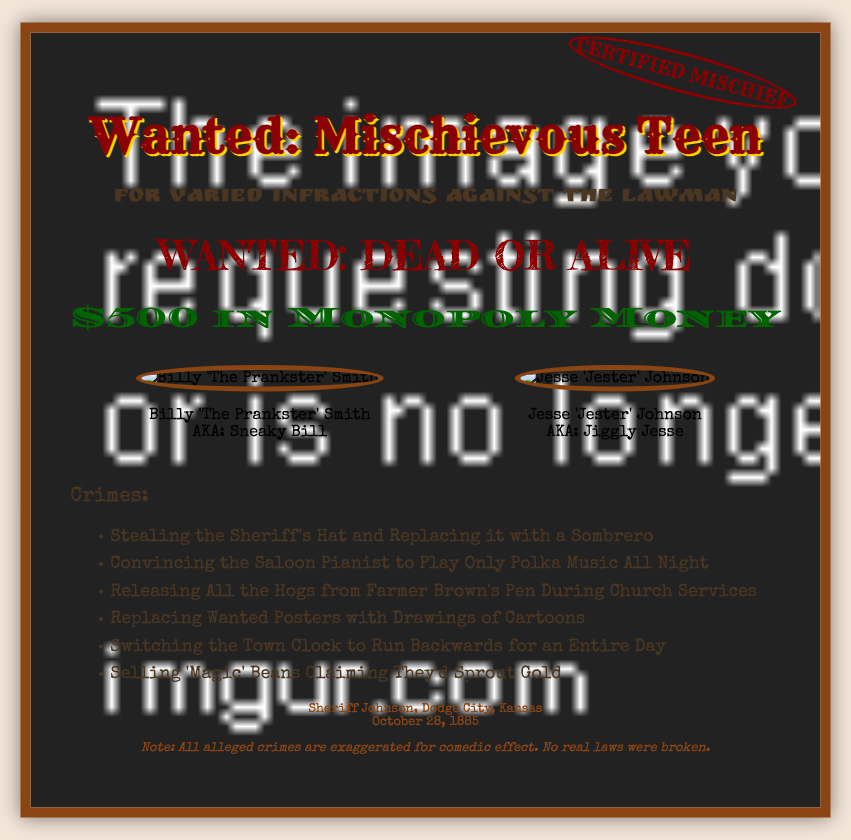What is the title of the document? The title is prominently displayed and refers to the subject of the wanted poster.
Answer: Wanted: Mischievous Teen What is the reward amount? The reward amount is clearly stated in a distinctive style within the document.
Answer: $500 in Monopoly Money Who is one of the individuals wanted? The document lists individuals along with their catchy nicknames.
Answer: Billy 'The Prankster' Smith What is one of the crimes listed? The document provides a humorous list of exaggerated crimes committed by the individuals featured.
Answer: Stealing the Sheriff's Hat and Replacing it with a Sombrero What date is mentioned in the footer? The footer includes a specific date related to the document or the sheriff's concerns.
Answer: October 28, 1885 How many mugshots are displayed? The document shows a visual representation of wanted individuals with their mugshots.
Answer: Two What is the unique feature in the design of the document? The document incorporates playful elements that mimic a specific style, enhancing its overall theme.
Answer: Old Western style What does the stamp say? The stamp adds a playful official touch to the poster, reinforcing its theme.
Answer: CERTIFIED MISCHIEF What is the sheriff's name mentioned? The footer contains the sheriff's name, linking it to the document's authority.
Answer: Sheriff Johnson 